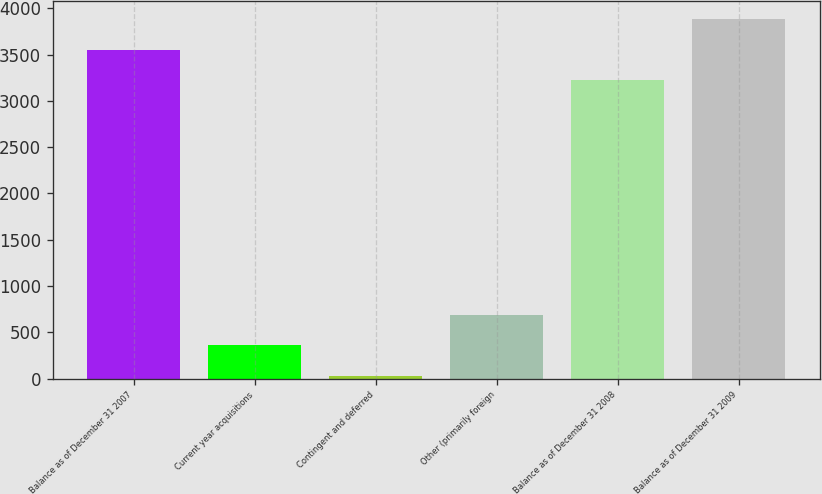<chart> <loc_0><loc_0><loc_500><loc_500><bar_chart><fcel>Balance as of December 31 2007<fcel>Current year acquisitions<fcel>Contingent and deferred<fcel>Other (primarily foreign<fcel>Balance as of December 31 2008<fcel>Balance as of December 31 2009<nl><fcel>3550<fcel>359.1<fcel>30<fcel>688.2<fcel>3220.9<fcel>3879.1<nl></chart> 